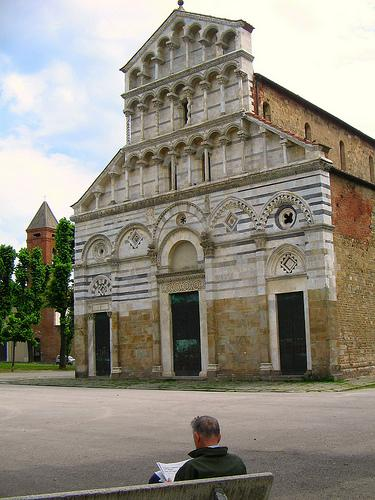Question: who is in the picture?
Choices:
A. A woman.
B. A boy.
C. A girl.
D. A man.
Answer with the letter. Answer: D Question: what is in the picture?
Choices:
A. A sidewalk.
B. An old building.
C. A road.
D. A brick wall.
Answer with the letter. Answer: B Question: what is the man reading?
Choices:
A. A book.
B. A magazine.
C. Pamphlet.
D. A newspaper.
Answer with the letter. Answer: D Question: what color is the man's hair?
Choices:
A. Black.
B. White.
C. Gray.
D. Red.
Answer with the letter. Answer: C 